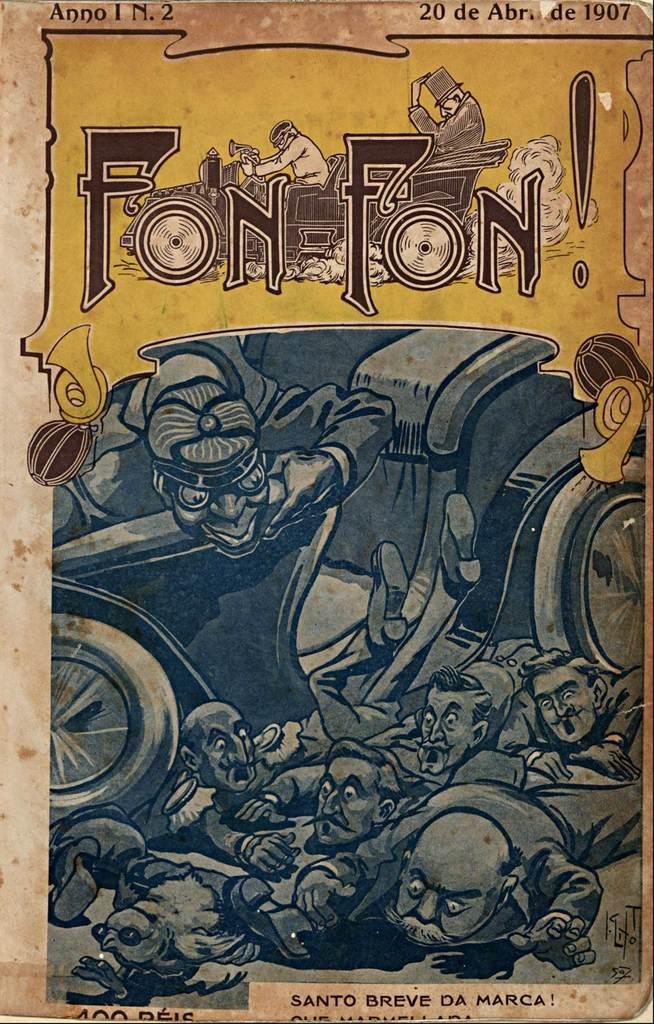Please provide a concise description of this image. In this picture we can see poster, in this poster we can see people and text. 